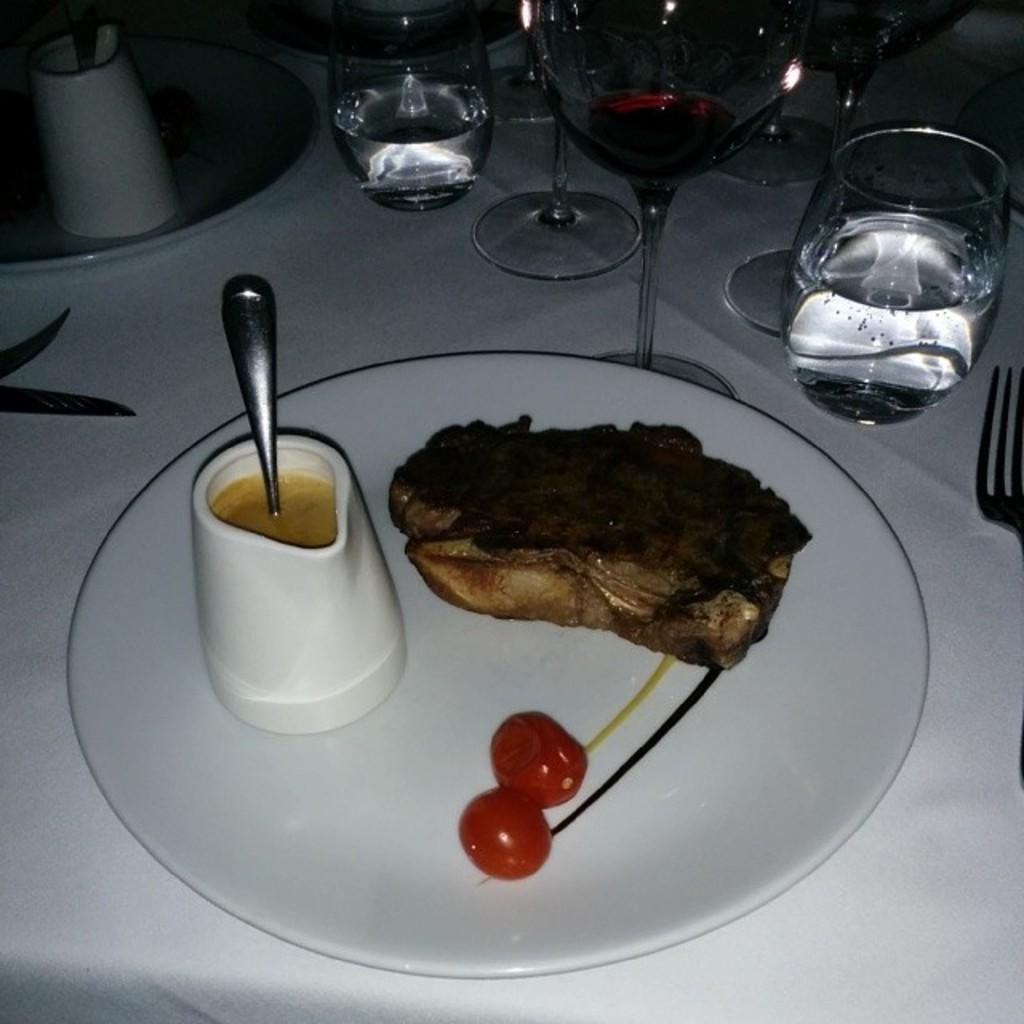What type of tableware can be seen on the table in the image? There are plates, water glasses, wine glasses, and forks on the table. What is in the white plate in the image? In the white plate, there is a jar, a spoon, fried fish, chocolate, and other objects. What type of reaction does the turkey have when it sees the servant in the image? There is no turkey or servant present in the image. 